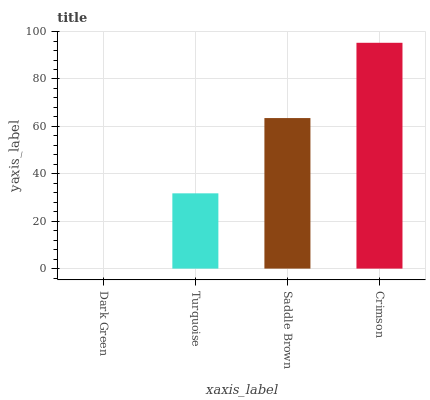Is Turquoise the minimum?
Answer yes or no. No. Is Turquoise the maximum?
Answer yes or no. No. Is Turquoise greater than Dark Green?
Answer yes or no. Yes. Is Dark Green less than Turquoise?
Answer yes or no. Yes. Is Dark Green greater than Turquoise?
Answer yes or no. No. Is Turquoise less than Dark Green?
Answer yes or no. No. Is Saddle Brown the high median?
Answer yes or no. Yes. Is Turquoise the low median?
Answer yes or no. Yes. Is Dark Green the high median?
Answer yes or no. No. Is Crimson the low median?
Answer yes or no. No. 